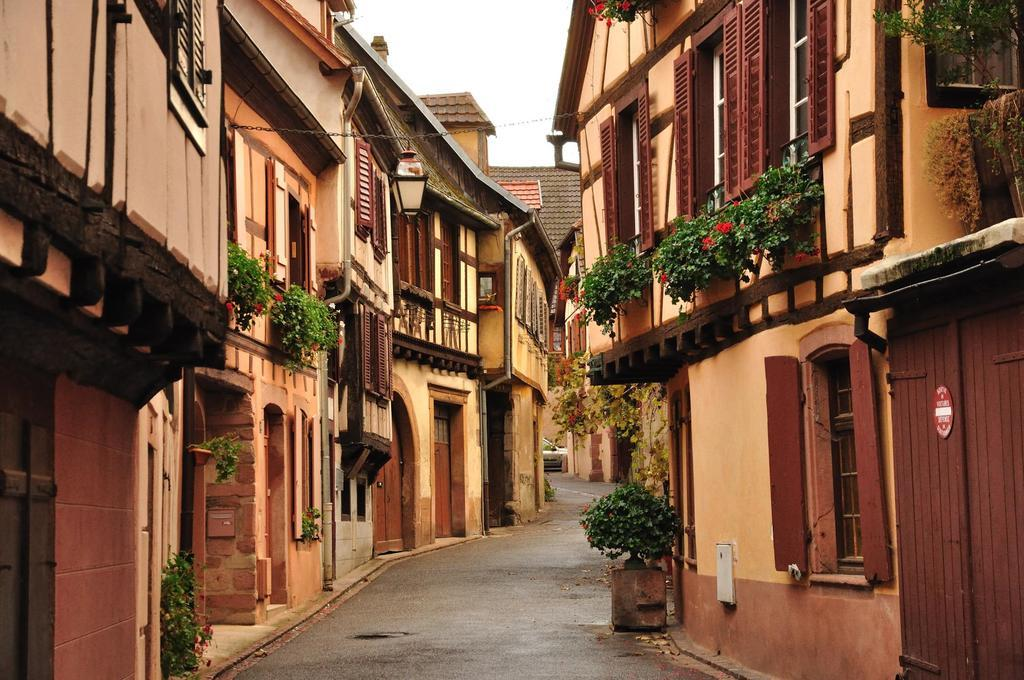What is the main feature of the image? There is a road in the image. What type of vehicle can be seen on the road? There is a car in the image. What type of indoor plants are visible in the image? There are houseplants in the image. What type of structures can be seen in the image? There are buildings with windows in the image. What is visible in the background of the image? The sky is visible in the background of the image. Where is the writer sitting in the image? There is no writer present in the image. What type of cave can be seen in the image? There is no cave present in the image. 